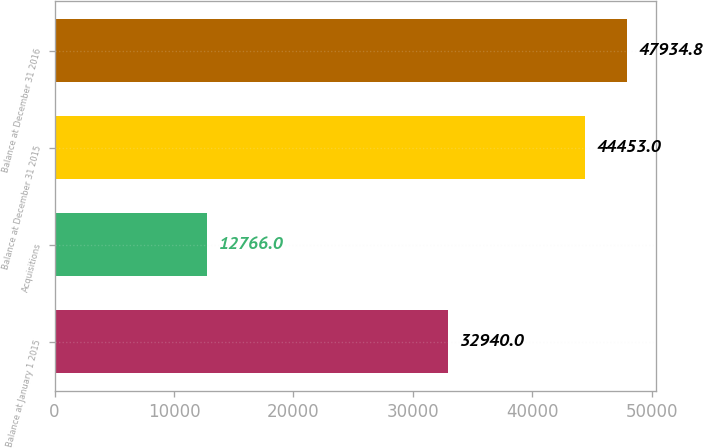Convert chart to OTSL. <chart><loc_0><loc_0><loc_500><loc_500><bar_chart><fcel>Balance at January 1 2015<fcel>Acquisitions<fcel>Balance at December 31 2015<fcel>Balance at December 31 2016<nl><fcel>32940<fcel>12766<fcel>44453<fcel>47934.8<nl></chart> 